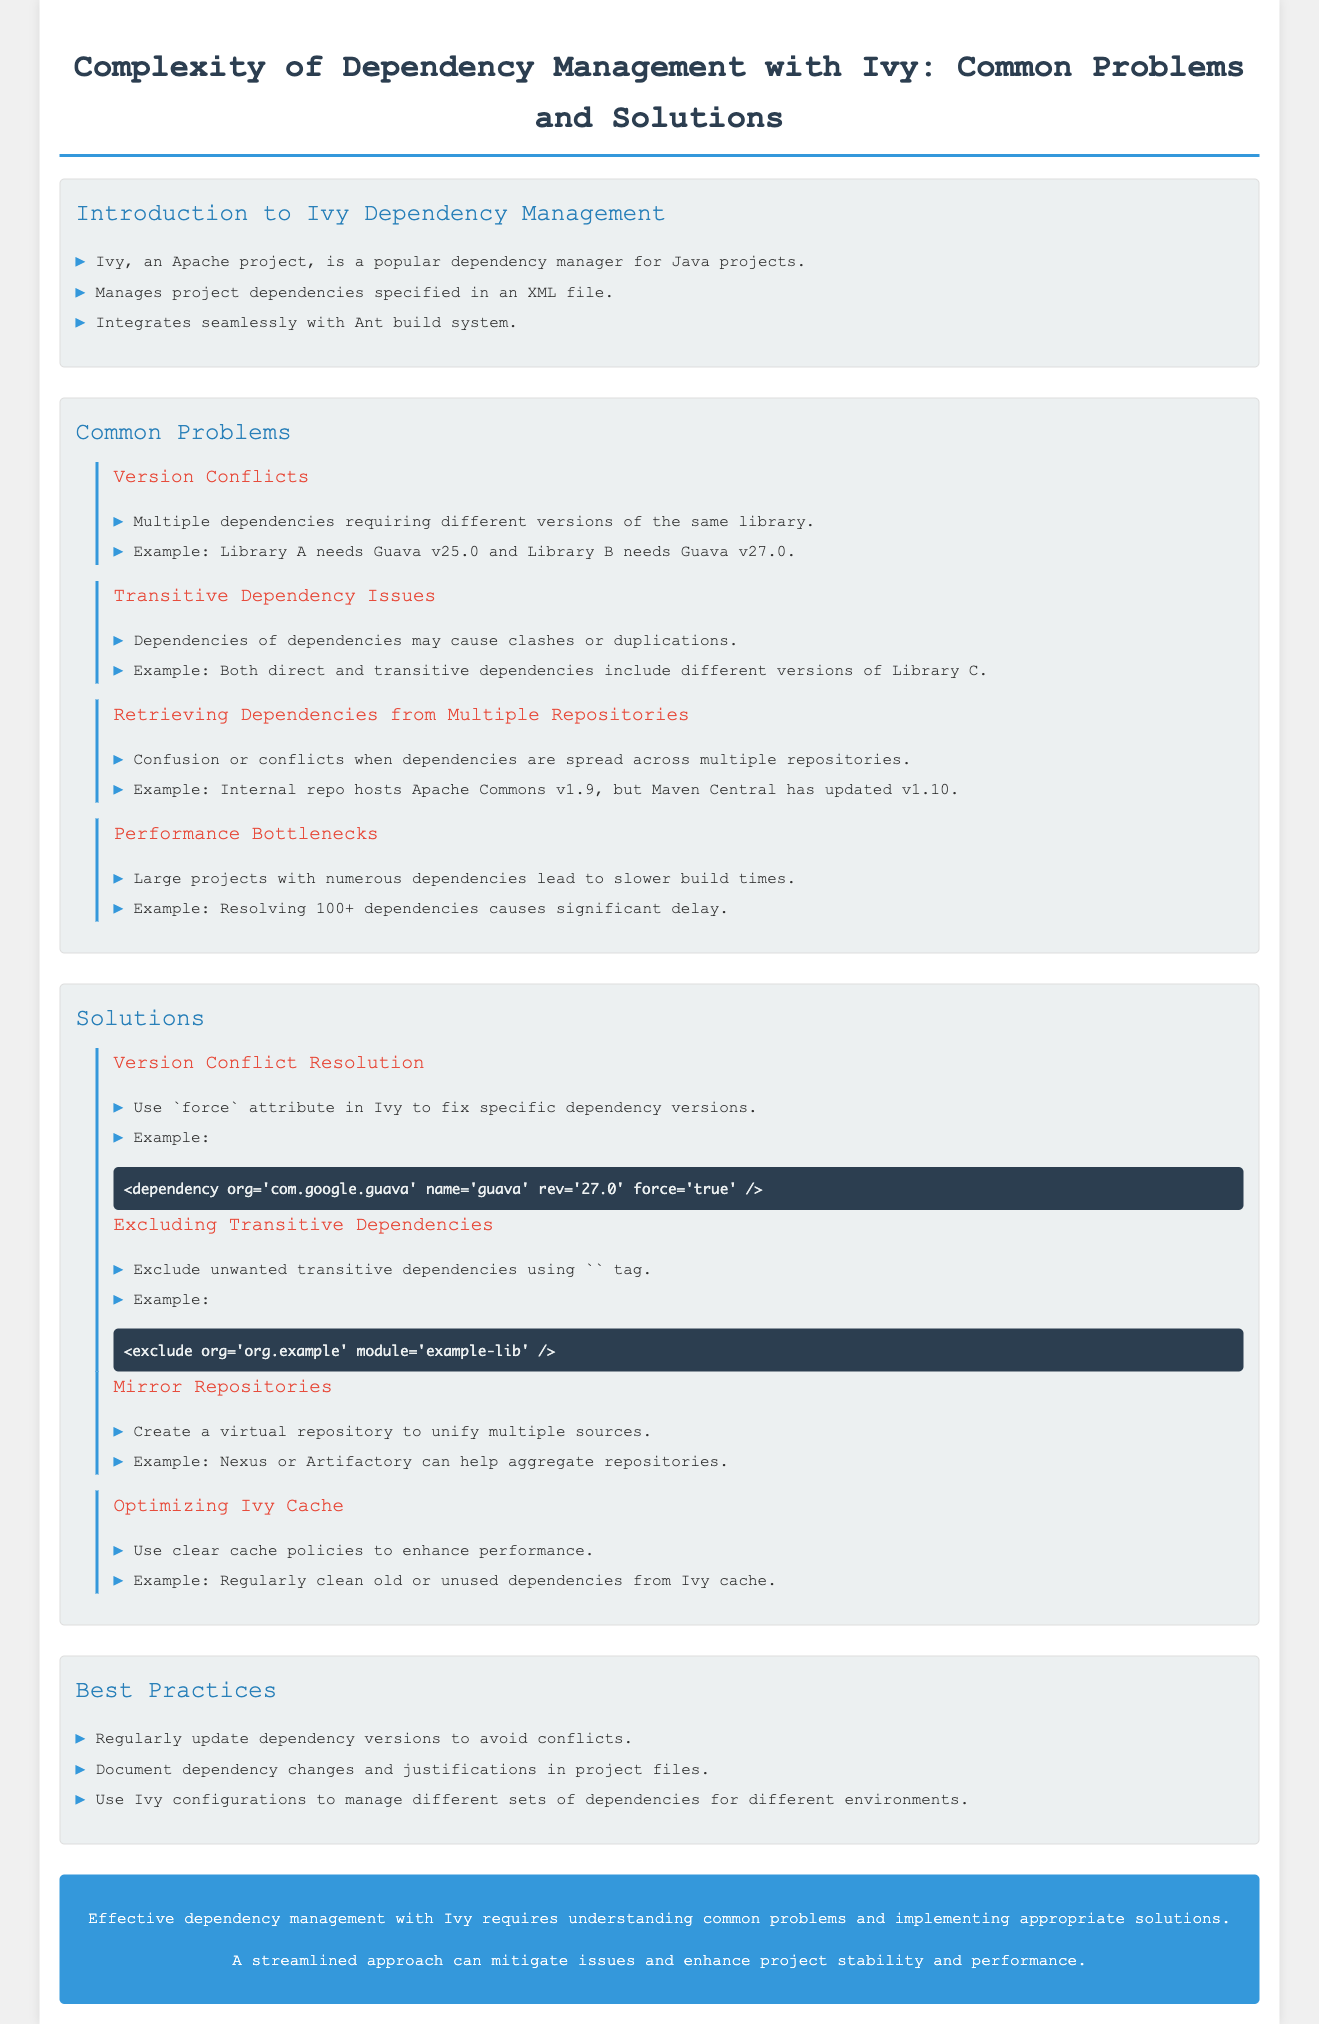What is Ivy? Ivy is an Apache project that is a popular dependency manager for Java projects.
Answer: An Apache project What is the first common problem listed? The first common problem mentioned in the document is "Version Conflicts."
Answer: Version Conflicts How many sub-sections are under Common Problems? There are four sub-sections under Common Problems.
Answer: Four What attribute can be used in Ivy to fix specific dependency versions? The attribute that can be used in Ivy to fix specific dependency versions is "force."
Answer: Force What is one way to resolve transitive dependency issues? One way to resolve transitive dependency issues is by excluding unwanted transitive dependencies using the exclude tag.
Answer: Exclude tag How can performance bottlenecks be optimized? Performance bottlenecks can be optimized by using clear cache policies.
Answer: Clear cache policies What is recommended to manage different sets of dependencies for different environments? The document recommends using Ivy configurations for managing different sets of dependencies for different environments.
Answer: Ivy configurations What are two recommended practices to avoid dependency conflicts? Regularly updating dependency versions and documenting dependency changes are recommended practices.
Answer: Update versions, document changes 